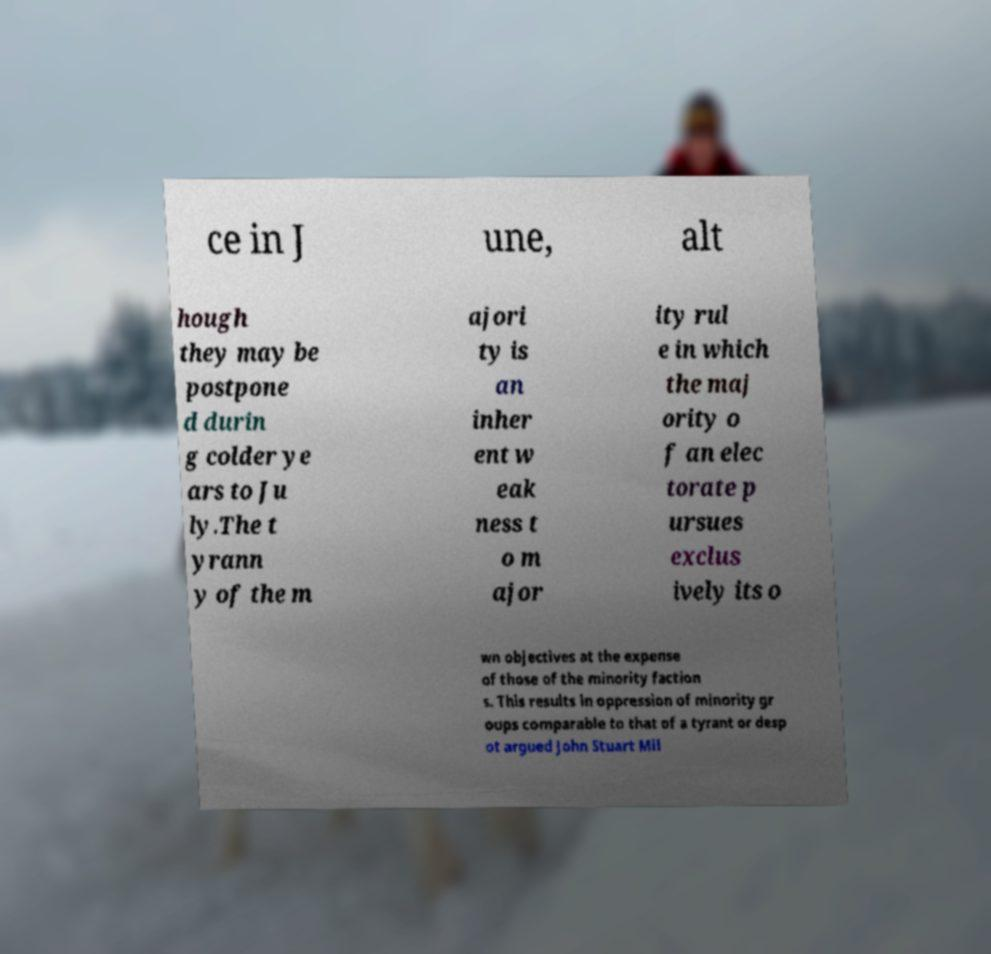What messages or text are displayed in this image? I need them in a readable, typed format. ce in J une, alt hough they may be postpone d durin g colder ye ars to Ju ly.The t yrann y of the m ajori ty is an inher ent w eak ness t o m ajor ity rul e in which the maj ority o f an elec torate p ursues exclus ively its o wn objectives at the expense of those of the minority faction s. This results in oppression of minority gr oups comparable to that of a tyrant or desp ot argued John Stuart Mil 